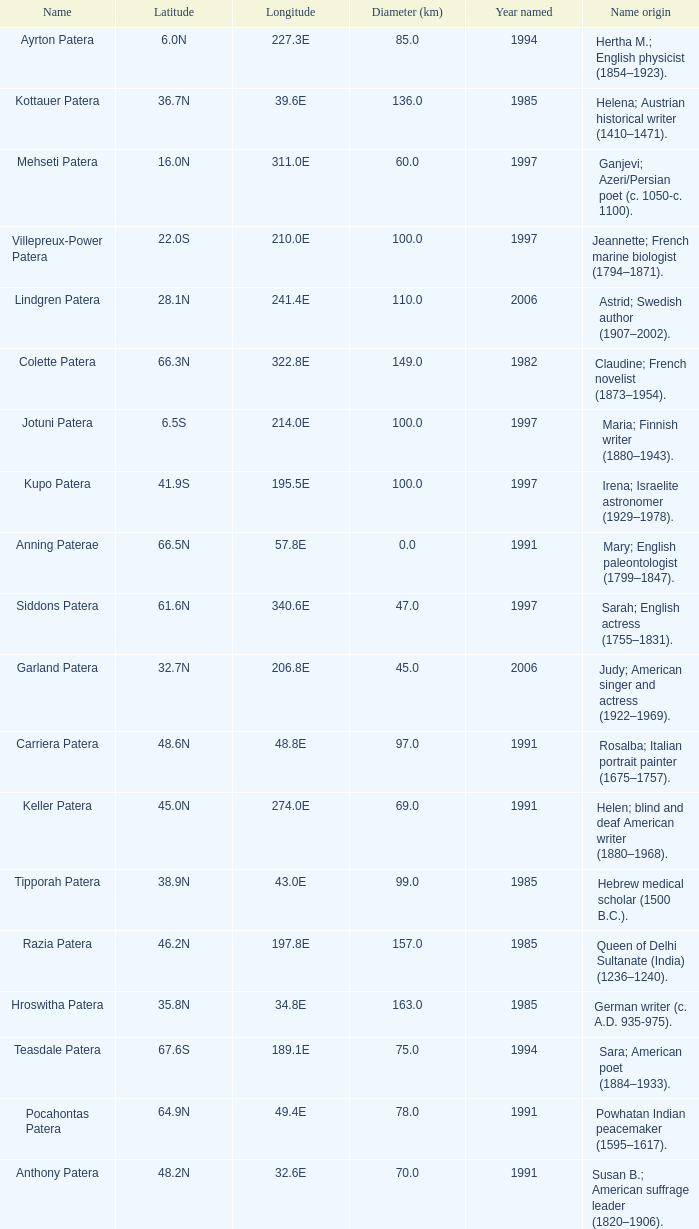What is the longitude of the feature named Razia Patera?  197.8E. 